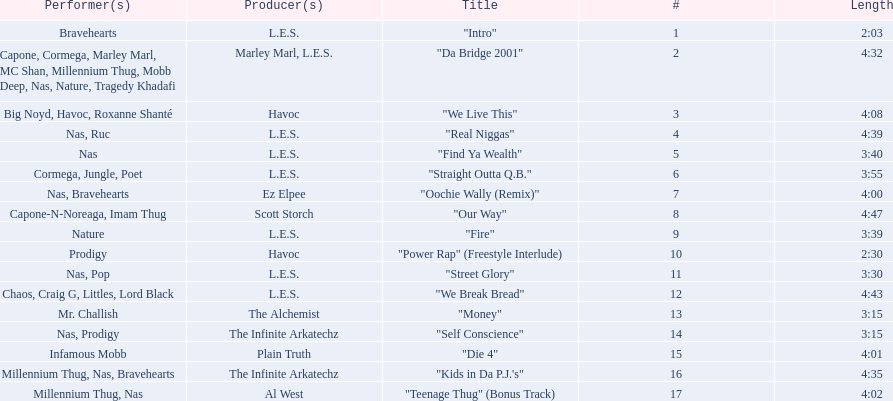How long is each song? 2:03, 4:32, 4:08, 4:39, 3:40, 3:55, 4:00, 4:47, 3:39, 2:30, 3:30, 4:43, 3:15, 3:15, 4:01, 4:35, 4:02. What length is the longest? 4:47. 